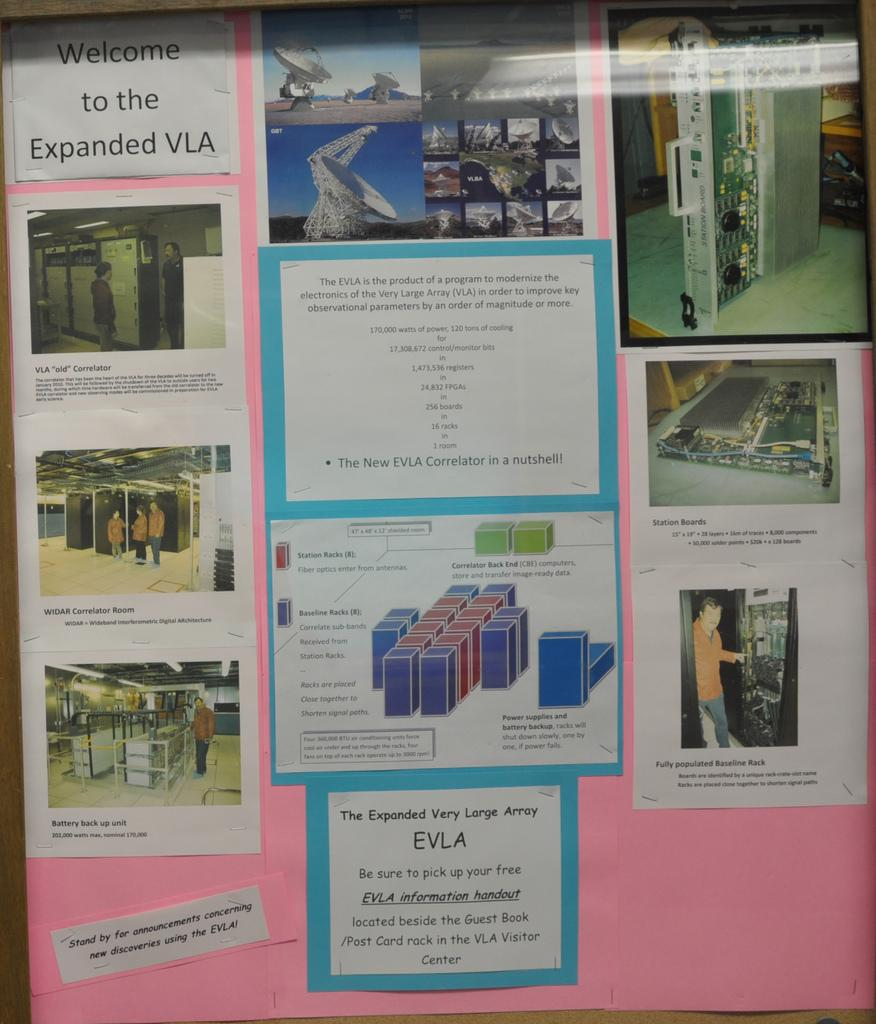<image>
Offer a succinct explanation of the picture presented. A poster showing the interior computers and other items says welcome on it. 